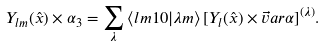Convert formula to latex. <formula><loc_0><loc_0><loc_500><loc_500>Y _ { l m } ( \hat { x } ) \times \alpha _ { 3 } = \sum _ { \lambda } \, \langle l m 1 0 | \lambda m \rangle \, [ Y _ { l } ( \hat { x } ) \times \vec { v } a r { \alpha } ] ^ { ( \lambda ) } .</formula> 